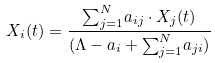<formula> <loc_0><loc_0><loc_500><loc_500>X _ { i } ( t ) = \frac { { \sum _ { j = 1 } ^ { N } } a _ { i j } \cdot X _ { j } ( t ) } { ( \Lambda - a _ { i } + { \sum _ { j = 1 } ^ { N } } a _ { j i } ) }</formula> 